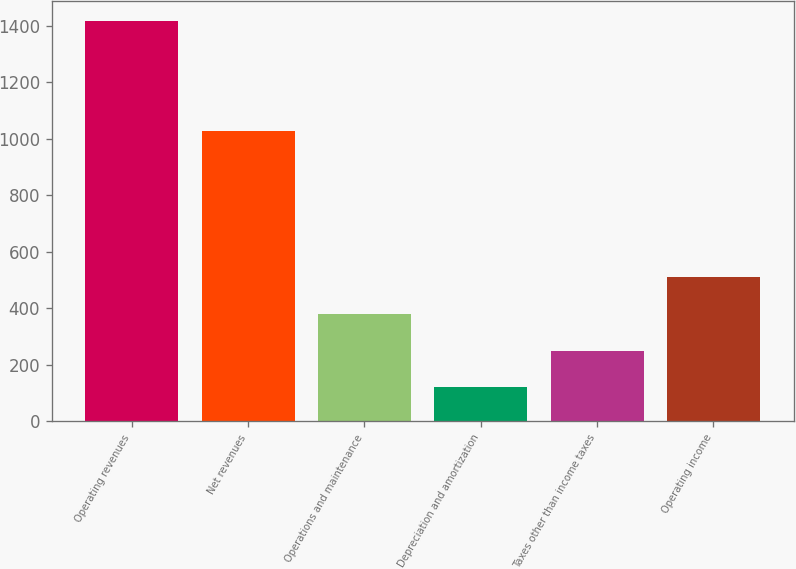<chart> <loc_0><loc_0><loc_500><loc_500><bar_chart><fcel>Operating revenues<fcel>Net revenues<fcel>Operations and maintenance<fcel>Depreciation and amortization<fcel>Taxes other than income taxes<fcel>Operating income<nl><fcel>1415<fcel>1028<fcel>379<fcel>120<fcel>249.5<fcel>508.5<nl></chart> 